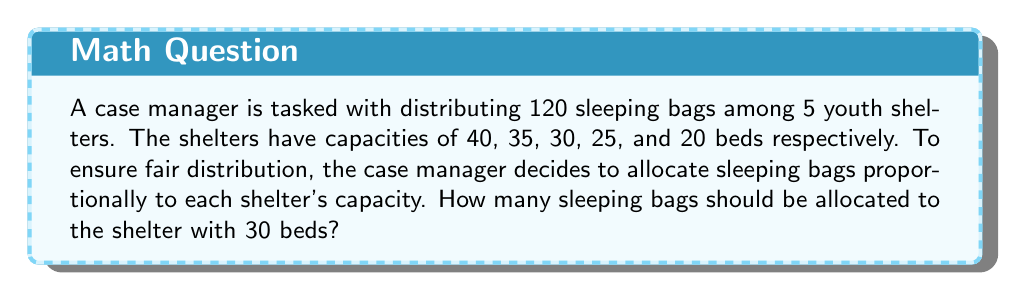Give your solution to this math problem. Let's approach this step-by-step:

1) First, we need to calculate the total capacity of all shelters:
   $40 + 35 + 30 + 25 + 20 = 150$ beds

2) Now, we need to find what fraction of the total capacity the 30-bed shelter represents:
   $\frac{30}{150} = \frac{1}{5}$

3) Since we want to distribute the sleeping bags proportionally, the 30-bed shelter should receive $\frac{1}{5}$ of the total sleeping bags.

4) To calculate this, we multiply the total number of sleeping bags by $\frac{1}{5}$:

   $$120 \times \frac{1}{5} = 24$$

Therefore, the shelter with 30 beds should receive 24 sleeping bags.
Answer: 24 sleeping bags 